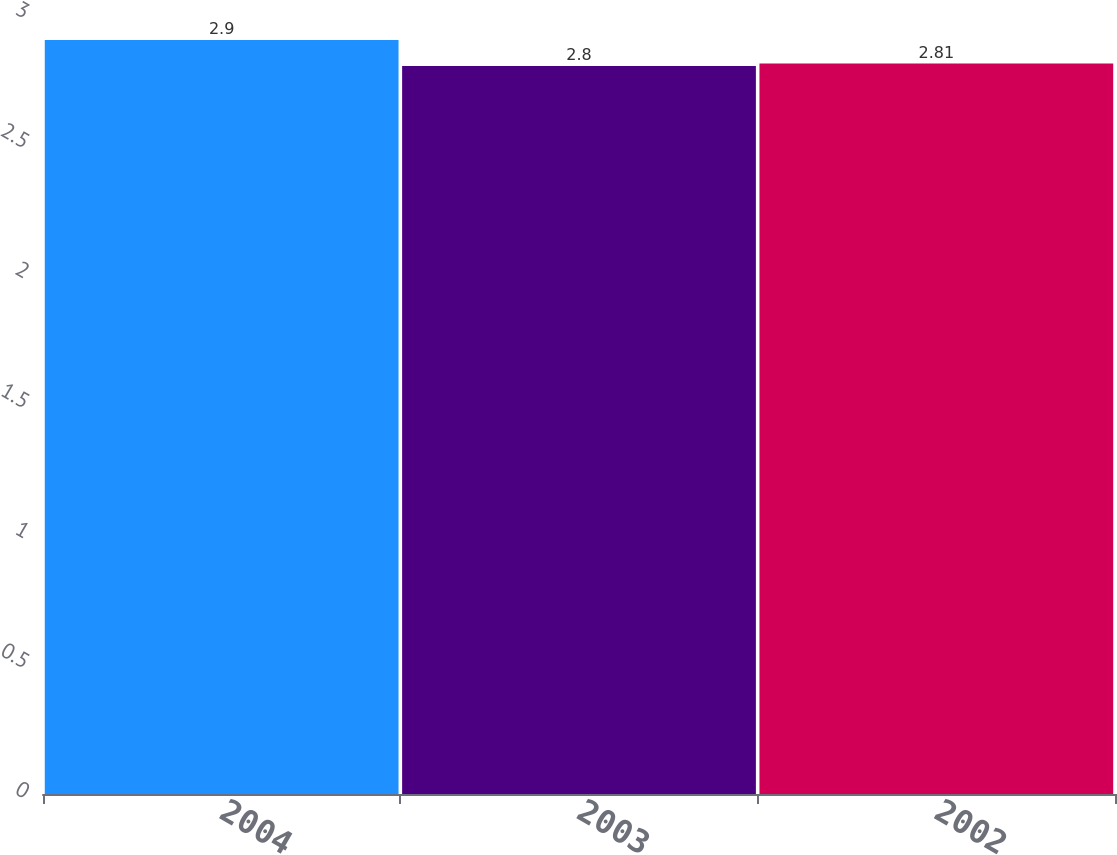Convert chart. <chart><loc_0><loc_0><loc_500><loc_500><bar_chart><fcel>2004<fcel>2003<fcel>2002<nl><fcel>2.9<fcel>2.8<fcel>2.81<nl></chart> 